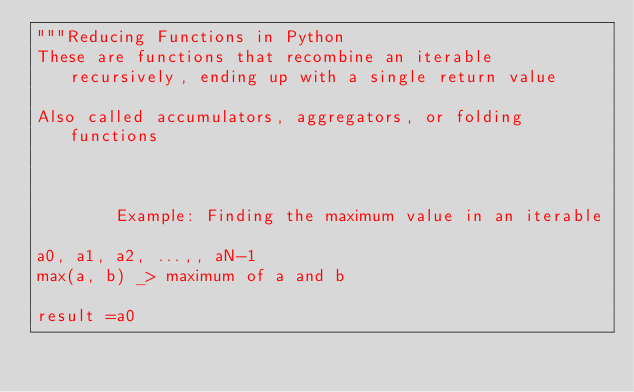<code> <loc_0><loc_0><loc_500><loc_500><_Python_>"""Reducing Functions in Python
These are functions that recombine an iterable recursively, ending up with a single return value

Also called accumulators, aggregators, or folding functions



        Example: Finding the maximum value in an iterable

a0, a1, a2, ...,, aN-1
max(a, b) _> maximum of a and b

result =a0</code> 